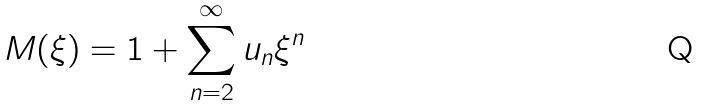<formula> <loc_0><loc_0><loc_500><loc_500>M ( \xi ) = 1 + \sum _ { n = 2 } ^ { \infty } u _ { n } \xi ^ { n }</formula> 